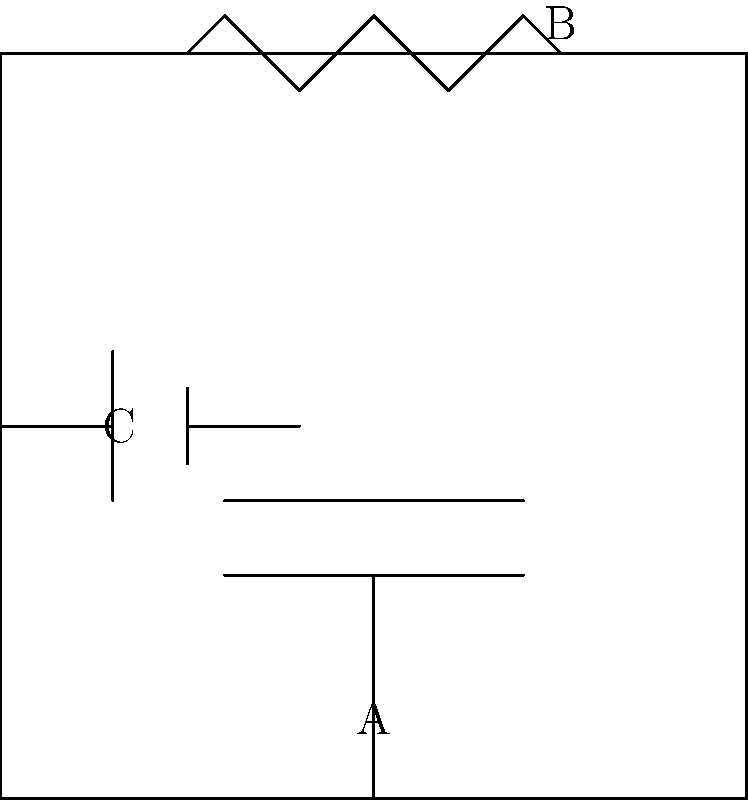In the circuit diagram above, which component is represented by the symbol labeled "B"? To answer this question, we need to identify the basic electrical circuit symbols in the diagram. Let's break it down step-by-step:

1. Symbol A: This symbol consists of two parallel lines, one longer than the other. In electrical engineering, this represents a capacitor.

2. Symbol B: This symbol shows a zigzag line. In circuit diagrams, a zigzag or wavy line typically represents a resistor.

3. Symbol C: This symbol shows a long line with a shorter line parallel to it. In electrical engineering, this symbol represents a battery or voltage source.

By examining these symbols and their standard representations in electrical engineering, we can conclude that the symbol labeled "B" in the diagram represents a resistor.

It's worth noting that in traditional Hawaiian culture, there may not be direct equivalents to these modern electrical components. However, we can draw parallels to natural elements:
- A resistor (B) could be likened to the way certain plants resist the flow of water, like how ti leaves are used to channel rainwater.
- The capacitor (A) might be compared to how some plants, like taro, store water in their corms.
- The battery (C) could be related to how certain plants, like the Hawaiian sugar cane, store energy.

These analogies can help bridge the gap between traditional knowledge and modern electrical engineering concepts.
Answer: Resistor 